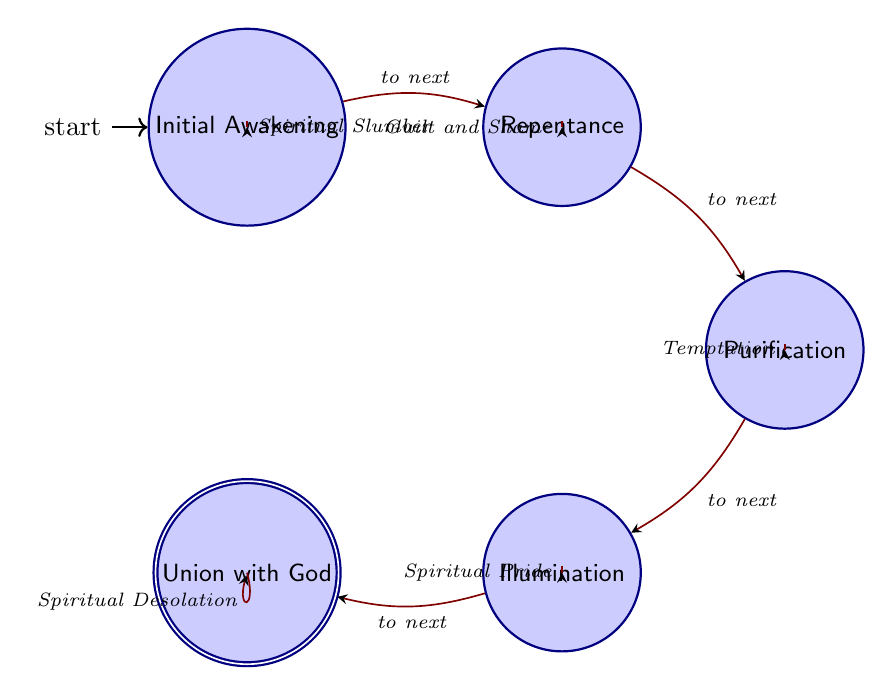What is the first state in the journey? The first state in the journey is explicitly labeled in the diagram and is identified as "Initial Awakening."
Answer: Initial Awakening How many states are represented in the diagram? By counting the nodes in the diagram, there are a total of five distinct states, which represent the key stages of the spiritual journey.
Answer: 5 What transition leads from Repentance? The diagram shows that the transition from Repentance leads to the next state, which is Purification.
Answer: Purification What is the transition that can lead to a state of failure from Illumination? The diagram indicates that from the Illumination state, the failure transition allows the possibility of falling into Spiritual Pride.
Answer: Spiritual Pride Which state represents the ultimate goal of the journey? The ultimate goal of the journey is clearly indicated in the diagram as the state "Union with God."
Answer: Union with God Which state is reached after acknowledging sins? According to the flow in the diagram, after the stage of acknowledging sins (Repentance), the next stage reached is Purification.
Answer: Purification What happens if one fails in the Purification stage? The diagram details that failing in the Purification stage results in the state of Temptation.
Answer: Temptation Is there a transition that loops back to an earlier state? Yes, the diagram indicates that there is a transition labeled "Spiritual Slumber" which loops back to the Initial Awakening state.
Answer: Spiritual Slumber What could lead to Spiritual Desolation? The diagram shows that once at the Union with God stage, a failure transition can lead to Spiritual Desolation.
Answer: Spiritual Desolation 